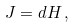Convert formula to latex. <formula><loc_0><loc_0><loc_500><loc_500>J = d H \, ,</formula> 